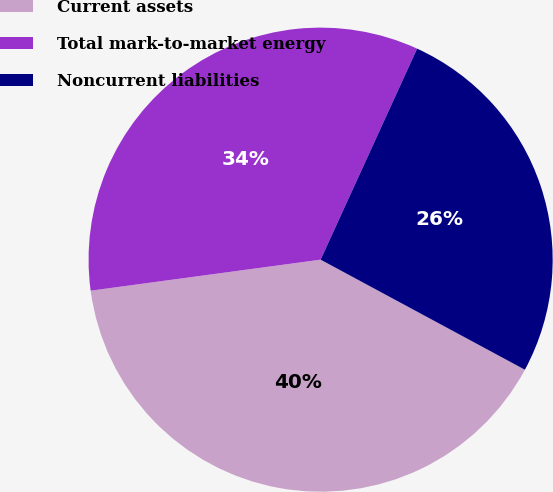<chart> <loc_0><loc_0><loc_500><loc_500><pie_chart><fcel>Current assets<fcel>Total mark-to-market energy<fcel>Noncurrent liabilities<nl><fcel>40.0%<fcel>33.96%<fcel>26.04%<nl></chart> 